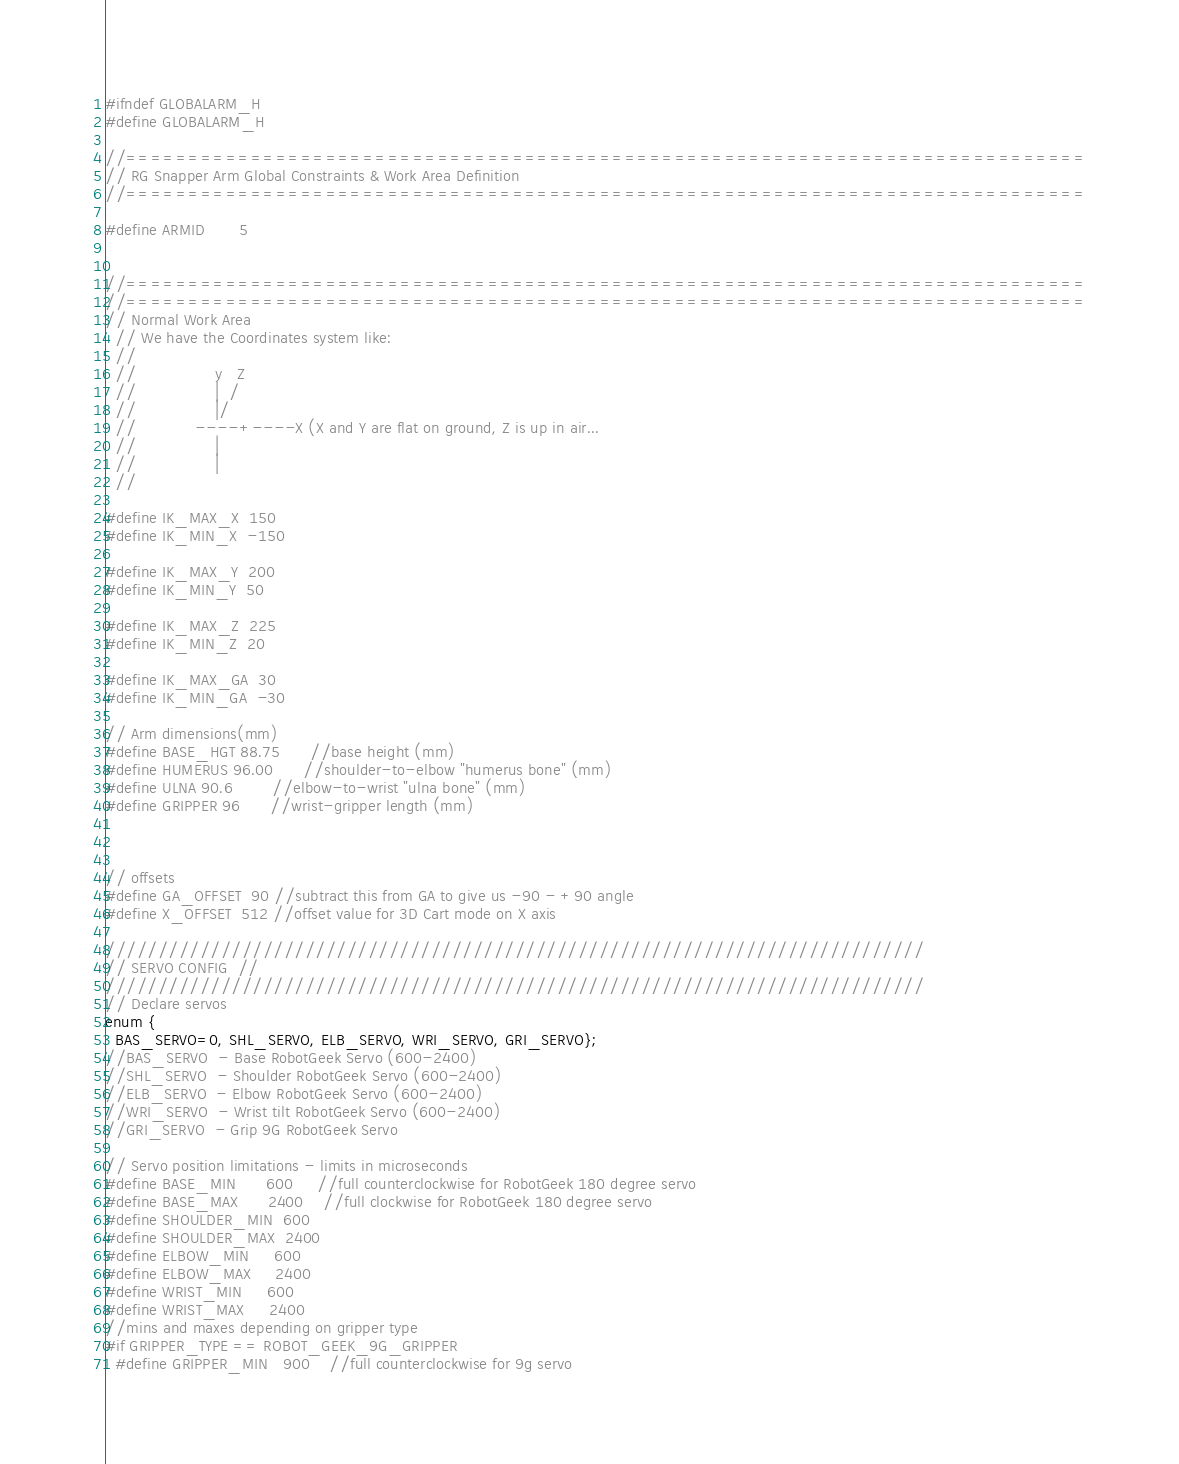Convert code to text. <code><loc_0><loc_0><loc_500><loc_500><_C_>#ifndef GLOBALARM_H
#define GLOBALARM_H

//=============================================================================
// RG Snapper Arm Global Constraints & Work Area Definition
//=============================================================================

#define ARMID       5


//=============================================================================
//=============================================================================
// Normal Work Area
  // We have the Coordinates system like:
  //
  //                y   Z
  //                |  /
  //                |/
  //            ----+----X (X and Y are flat on ground, Z is up in air...
  //                |
  //                |
  //

#define IK_MAX_X  150
#define IK_MIN_X  -150

#define IK_MAX_Y  200
#define IK_MIN_Y  50

#define IK_MAX_Z  225
#define IK_MIN_Z  20

#define IK_MAX_GA  30
#define IK_MIN_GA  -30

// Arm dimensions(mm)
#define BASE_HGT 88.75      //base height (mm)
#define HUMERUS 96.00      //shoulder-to-elbow "humerus bone" (mm)
#define ULNA 90.6        //elbow-to-wrist "ulna bone" (mm)
#define GRIPPER 96      //wrist-gripper length (mm)



// offsets 
#define GA_OFFSET  90 //subtract this from GA to give us -90 - +90 angle
#define X_OFFSET  512 //offset value for 3D Cart mode on X axis

//////////////////////////////////////////////////////////////////////////////
// SERVO CONFIG  //
//////////////////////////////////////////////////////////////////////////////
// Declare servos
enum {
  BAS_SERVO=0, SHL_SERVO, ELB_SERVO, WRI_SERVO, GRI_SERVO};
//BAS_SERVO  - Base RobotGeek Servo (600-2400)
//SHL_SERVO  - Shoulder RobotGeek Servo (600-2400)
//ELB_SERVO  - Elbow RobotGeek Servo (600-2400)
//WRI_SERVO  - Wrist tilt RobotGeek Servo (600-2400)
//GRI_SERVO  - Grip 9G RobotGeek Servo

// Servo position limitations - limits in microseconds
#define BASE_MIN      600     //full counterclockwise for RobotGeek 180 degree servo
#define BASE_MAX      2400    //full clockwise for RobotGeek 180 degree servo
#define SHOULDER_MIN  600
#define SHOULDER_MAX  2400
#define ELBOW_MIN     600
#define ELBOW_MAX     2400
#define WRIST_MIN     600
#define WRIST_MAX     2400 
//mins and maxes depending on gripper type
#if GRIPPER_TYPE == ROBOT_GEEK_9G_GRIPPER
  #define GRIPPER_MIN   900    //full counterclockwise for 9g servo</code> 